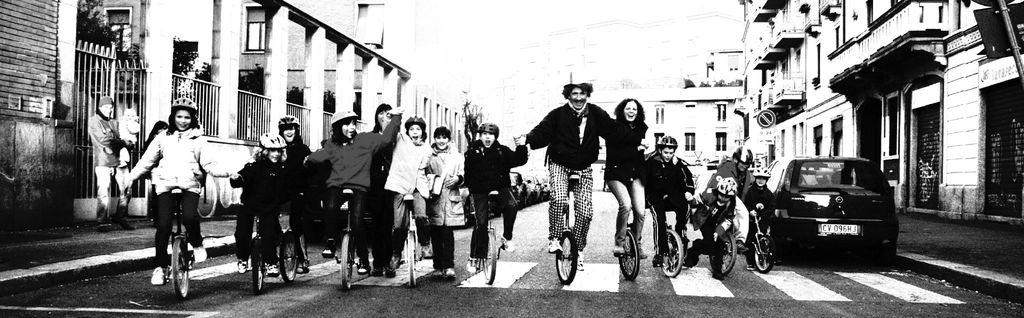What is the color scheme of the image? The image is black and white. What activity are the people in the image engaged in? There is a group of people riding bicycles in the image. What else can be seen on the road in the image? There are vehicles on the road in the image. What structures are visible in the image? There are buildings in the image. What type of vegetation can be seen in the image? There are trees in the image. What architectural feature is present in the image? There are iron grilles in the image. Can you see any feathers floating in the air in the image? No, there are no feathers visible in the image. What type of crib is present in the image? There is no crib present in the image. 